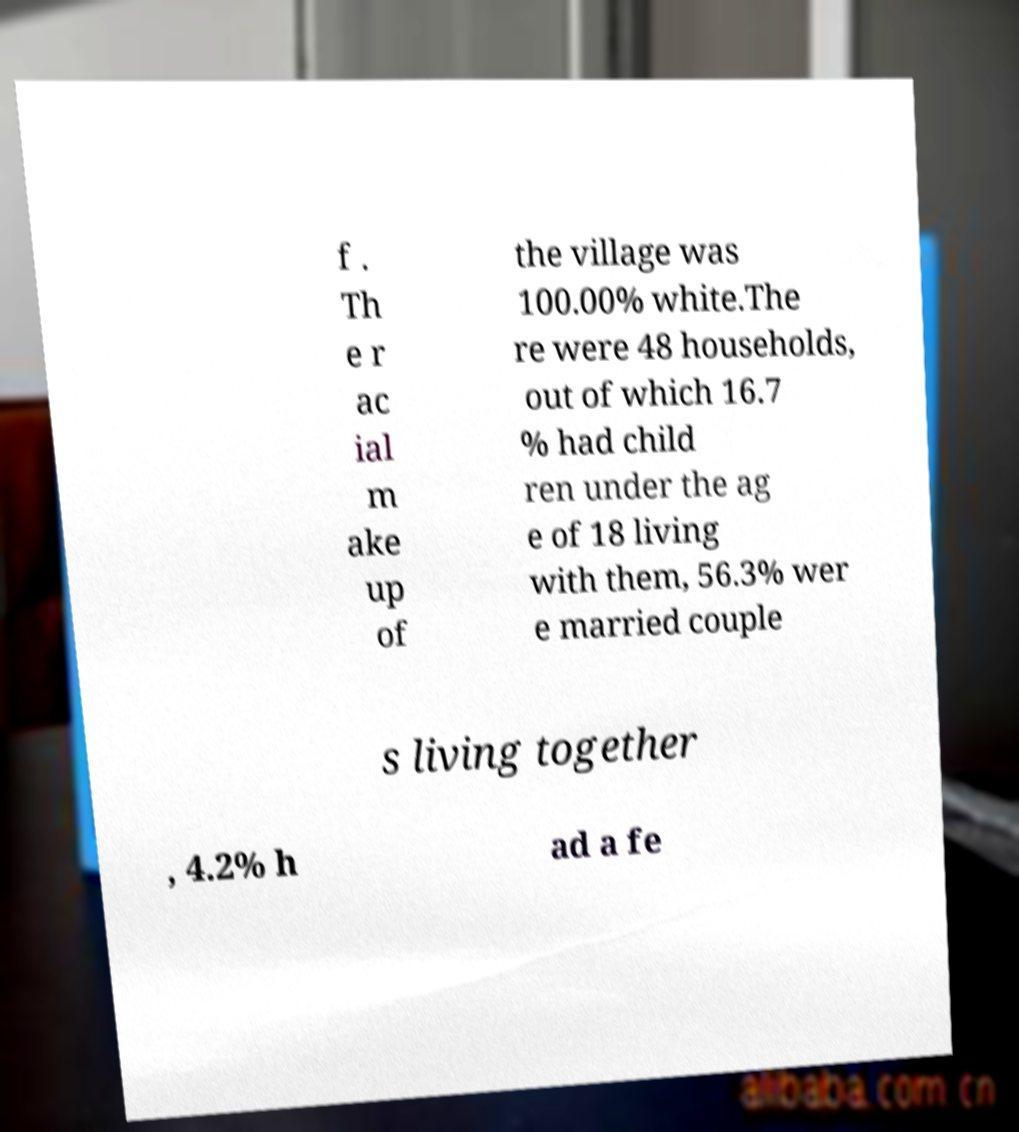Please read and relay the text visible in this image. What does it say? f . Th e r ac ial m ake up of the village was 100.00% white.The re were 48 households, out of which 16.7 % had child ren under the ag e of 18 living with them, 56.3% wer e married couple s living together , 4.2% h ad a fe 